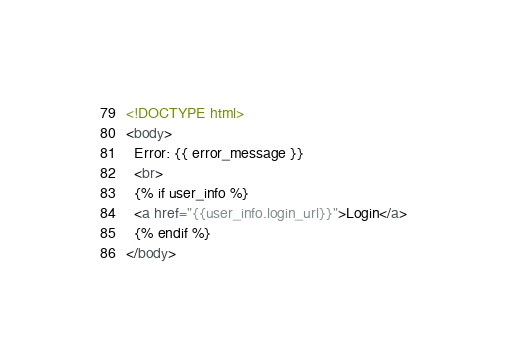Convert code to text. <code><loc_0><loc_0><loc_500><loc_500><_HTML_><!DOCTYPE html>
<body>
  Error: {{ error_message }}
  <br>
  {% if user_info %}
  <a href="{{user_info.login_url}}">Login</a>
  {% endif %}
</body>
</code> 